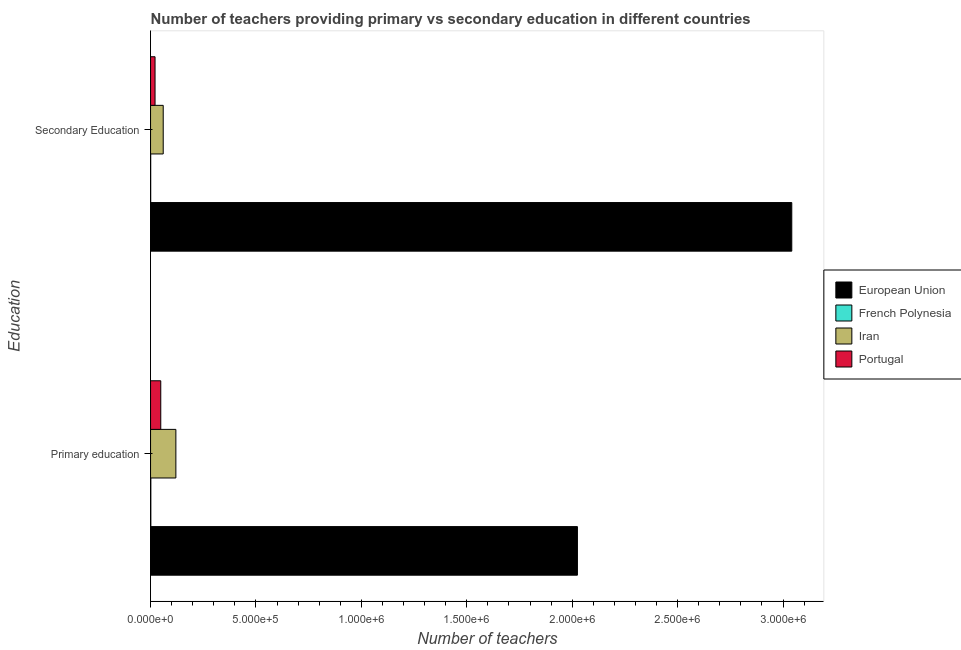How many groups of bars are there?
Your answer should be very brief. 2. Are the number of bars per tick equal to the number of legend labels?
Provide a succinct answer. Yes. Are the number of bars on each tick of the Y-axis equal?
Your answer should be very brief. Yes. How many bars are there on the 2nd tick from the top?
Keep it short and to the point. 4. How many bars are there on the 2nd tick from the bottom?
Keep it short and to the point. 4. What is the label of the 1st group of bars from the top?
Your response must be concise. Secondary Education. What is the number of primary teachers in French Polynesia?
Your answer should be very brief. 1213. Across all countries, what is the maximum number of secondary teachers?
Make the answer very short. 3.04e+06. Across all countries, what is the minimum number of primary teachers?
Make the answer very short. 1213. In which country was the number of primary teachers minimum?
Provide a succinct answer. French Polynesia. What is the total number of secondary teachers in the graph?
Provide a succinct answer. 3.12e+06. What is the difference between the number of primary teachers in Iran and that in Portugal?
Offer a very short reply. 7.17e+04. What is the difference between the number of secondary teachers in Portugal and the number of primary teachers in European Union?
Your response must be concise. -2.00e+06. What is the average number of secondary teachers per country?
Keep it short and to the point. 7.81e+05. What is the difference between the number of primary teachers and number of secondary teachers in French Polynesia?
Provide a succinct answer. 655. In how many countries, is the number of secondary teachers greater than 2500000 ?
Your response must be concise. 1. What is the ratio of the number of primary teachers in European Union to that in Portugal?
Offer a terse response. 41.87. What does the 1st bar from the top in Secondary Education represents?
Provide a short and direct response. Portugal. What does the 4th bar from the bottom in Secondary Education represents?
Your response must be concise. Portugal. How many bars are there?
Offer a terse response. 8. Are all the bars in the graph horizontal?
Ensure brevity in your answer.  Yes. What is the difference between two consecutive major ticks on the X-axis?
Keep it short and to the point. 5.00e+05. Are the values on the major ticks of X-axis written in scientific E-notation?
Offer a very short reply. Yes. Does the graph contain any zero values?
Offer a very short reply. No. What is the title of the graph?
Ensure brevity in your answer.  Number of teachers providing primary vs secondary education in different countries. Does "Marshall Islands" appear as one of the legend labels in the graph?
Ensure brevity in your answer.  No. What is the label or title of the X-axis?
Give a very brief answer. Number of teachers. What is the label or title of the Y-axis?
Ensure brevity in your answer.  Education. What is the Number of teachers of European Union in Primary education?
Give a very brief answer. 2.02e+06. What is the Number of teachers of French Polynesia in Primary education?
Keep it short and to the point. 1213. What is the Number of teachers in Iran in Primary education?
Offer a terse response. 1.20e+05. What is the Number of teachers in Portugal in Primary education?
Your answer should be very brief. 4.84e+04. What is the Number of teachers of European Union in Secondary Education?
Ensure brevity in your answer.  3.04e+06. What is the Number of teachers of French Polynesia in Secondary Education?
Your answer should be very brief. 558. What is the Number of teachers in Iran in Secondary Education?
Give a very brief answer. 6.00e+04. What is the Number of teachers of Portugal in Secondary Education?
Provide a succinct answer. 2.12e+04. Across all Education, what is the maximum Number of teachers in European Union?
Give a very brief answer. 3.04e+06. Across all Education, what is the maximum Number of teachers in French Polynesia?
Ensure brevity in your answer.  1213. Across all Education, what is the maximum Number of teachers of Iran?
Keep it short and to the point. 1.20e+05. Across all Education, what is the maximum Number of teachers in Portugal?
Give a very brief answer. 4.84e+04. Across all Education, what is the minimum Number of teachers of European Union?
Keep it short and to the point. 2.02e+06. Across all Education, what is the minimum Number of teachers of French Polynesia?
Offer a terse response. 558. Across all Education, what is the minimum Number of teachers in Iran?
Keep it short and to the point. 6.00e+04. Across all Education, what is the minimum Number of teachers of Portugal?
Offer a very short reply. 2.12e+04. What is the total Number of teachers of European Union in the graph?
Your response must be concise. 5.07e+06. What is the total Number of teachers of French Polynesia in the graph?
Your answer should be very brief. 1771. What is the total Number of teachers of Iran in the graph?
Provide a short and direct response. 1.80e+05. What is the total Number of teachers in Portugal in the graph?
Keep it short and to the point. 6.96e+04. What is the difference between the Number of teachers of European Union in Primary education and that in Secondary Education?
Provide a succinct answer. -1.02e+06. What is the difference between the Number of teachers of French Polynesia in Primary education and that in Secondary Education?
Give a very brief answer. 655. What is the difference between the Number of teachers in Iran in Primary education and that in Secondary Education?
Provide a succinct answer. 6.00e+04. What is the difference between the Number of teachers in Portugal in Primary education and that in Secondary Education?
Keep it short and to the point. 2.71e+04. What is the difference between the Number of teachers of European Union in Primary education and the Number of teachers of French Polynesia in Secondary Education?
Your answer should be very brief. 2.02e+06. What is the difference between the Number of teachers in European Union in Primary education and the Number of teachers in Iran in Secondary Education?
Provide a succinct answer. 1.96e+06. What is the difference between the Number of teachers in European Union in Primary education and the Number of teachers in Portugal in Secondary Education?
Keep it short and to the point. 2.00e+06. What is the difference between the Number of teachers of French Polynesia in Primary education and the Number of teachers of Iran in Secondary Education?
Your answer should be very brief. -5.88e+04. What is the difference between the Number of teachers in French Polynesia in Primary education and the Number of teachers in Portugal in Secondary Education?
Provide a succinct answer. -2.00e+04. What is the difference between the Number of teachers of Iran in Primary education and the Number of teachers of Portugal in Secondary Education?
Your answer should be very brief. 9.88e+04. What is the average Number of teachers of European Union per Education?
Offer a terse response. 2.53e+06. What is the average Number of teachers in French Polynesia per Education?
Your answer should be compact. 885.5. What is the average Number of teachers of Iran per Education?
Your answer should be very brief. 9.00e+04. What is the average Number of teachers in Portugal per Education?
Offer a very short reply. 3.48e+04. What is the difference between the Number of teachers in European Union and Number of teachers in French Polynesia in Primary education?
Make the answer very short. 2.02e+06. What is the difference between the Number of teachers of European Union and Number of teachers of Iran in Primary education?
Your answer should be compact. 1.90e+06. What is the difference between the Number of teachers of European Union and Number of teachers of Portugal in Primary education?
Provide a short and direct response. 1.98e+06. What is the difference between the Number of teachers of French Polynesia and Number of teachers of Iran in Primary education?
Keep it short and to the point. -1.19e+05. What is the difference between the Number of teachers in French Polynesia and Number of teachers in Portugal in Primary education?
Offer a terse response. -4.71e+04. What is the difference between the Number of teachers of Iran and Number of teachers of Portugal in Primary education?
Make the answer very short. 7.17e+04. What is the difference between the Number of teachers of European Union and Number of teachers of French Polynesia in Secondary Education?
Make the answer very short. 3.04e+06. What is the difference between the Number of teachers in European Union and Number of teachers in Iran in Secondary Education?
Offer a very short reply. 2.98e+06. What is the difference between the Number of teachers of European Union and Number of teachers of Portugal in Secondary Education?
Your answer should be compact. 3.02e+06. What is the difference between the Number of teachers in French Polynesia and Number of teachers in Iran in Secondary Education?
Ensure brevity in your answer.  -5.95e+04. What is the difference between the Number of teachers of French Polynesia and Number of teachers of Portugal in Secondary Education?
Provide a short and direct response. -2.07e+04. What is the difference between the Number of teachers in Iran and Number of teachers in Portugal in Secondary Education?
Offer a terse response. 3.88e+04. What is the ratio of the Number of teachers of European Union in Primary education to that in Secondary Education?
Give a very brief answer. 0.67. What is the ratio of the Number of teachers of French Polynesia in Primary education to that in Secondary Education?
Offer a very short reply. 2.17. What is the ratio of the Number of teachers in Iran in Primary education to that in Secondary Education?
Make the answer very short. 2. What is the ratio of the Number of teachers of Portugal in Primary education to that in Secondary Education?
Your answer should be compact. 2.28. What is the difference between the highest and the second highest Number of teachers of European Union?
Provide a short and direct response. 1.02e+06. What is the difference between the highest and the second highest Number of teachers in French Polynesia?
Make the answer very short. 655. What is the difference between the highest and the second highest Number of teachers in Iran?
Give a very brief answer. 6.00e+04. What is the difference between the highest and the second highest Number of teachers of Portugal?
Your answer should be very brief. 2.71e+04. What is the difference between the highest and the lowest Number of teachers of European Union?
Ensure brevity in your answer.  1.02e+06. What is the difference between the highest and the lowest Number of teachers of French Polynesia?
Your answer should be compact. 655. What is the difference between the highest and the lowest Number of teachers in Iran?
Make the answer very short. 6.00e+04. What is the difference between the highest and the lowest Number of teachers in Portugal?
Give a very brief answer. 2.71e+04. 